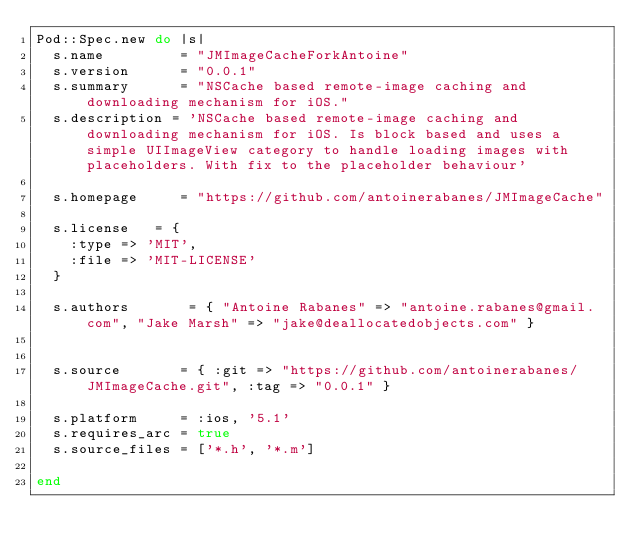Convert code to text. <code><loc_0><loc_0><loc_500><loc_500><_Ruby_>Pod::Spec.new do |s|
  s.name         = "JMImageCacheForkAntoine"
  s.version      = "0.0.1"
  s.summary      = "NSCache based remote-image caching and downloading mechanism for iOS."
  s.description = 'NSCache based remote-image caching and downloading mechanism for iOS. Is block based and uses a simple UIImageView category to handle loading images with placeholders. With fix to the placeholder behaviour'

  s.homepage     = "https://github.com/antoinerabanes/JMImageCache"

  s.license   = {
    :type => 'MIT',
    :file => 'MIT-LICENSE'
  }

  s.authors       = { "Antoine Rabanes" => "antoine.rabanes@gmail.com", "Jake Marsh" => "jake@deallocatedobjects.com" }


  s.source       = { :git => "https://github.com/antoinerabanes/JMImageCache.git", :tag => "0.0.1" }

  s.platform     = :ios, '5.1'
  s.requires_arc = true
  s.source_files = ['*.h', '*.m']
	
end
</code> 